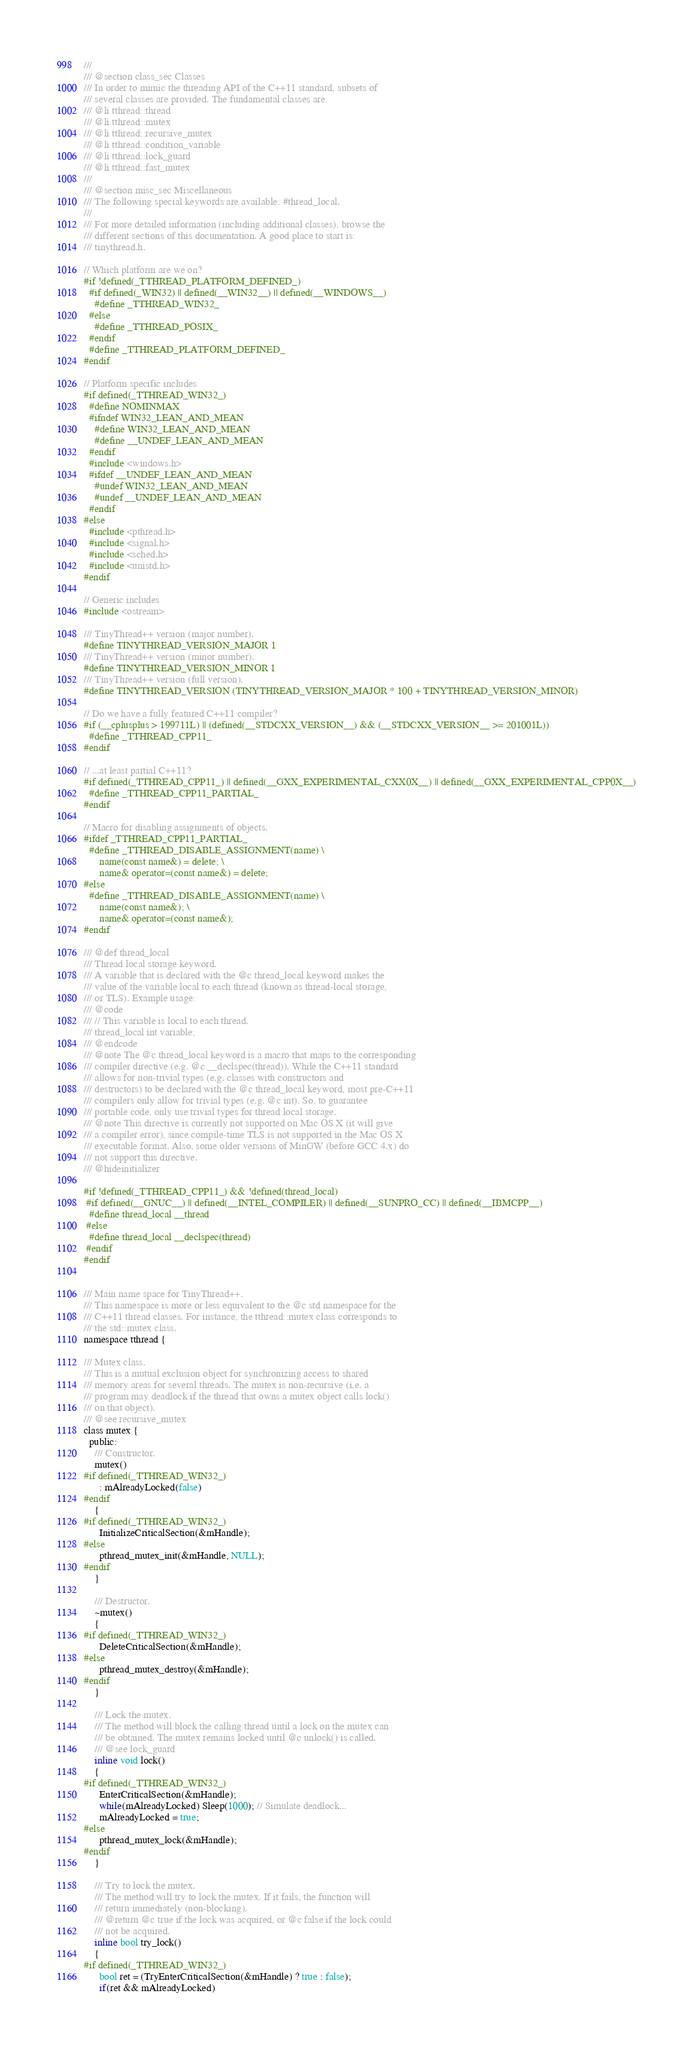Convert code to text. <code><loc_0><loc_0><loc_500><loc_500><_C_>///
/// @section class_sec Classes
/// In order to mimic the threading API of the C++11 standard, subsets of
/// several classes are provided. The fundamental classes are:
/// @li tthread::thread
/// @li tthread::mutex
/// @li tthread::recursive_mutex
/// @li tthread::condition_variable
/// @li tthread::lock_guard
/// @li tthread::fast_mutex
///
/// @section misc_sec Miscellaneous
/// The following special keywords are available: #thread_local.
///
/// For more detailed information (including additional classes), browse the
/// different sections of this documentation. A good place to start is:
/// tinythread.h.

// Which platform are we on?
#if !defined(_TTHREAD_PLATFORM_DEFINED_)
  #if defined(_WIN32) || defined(__WIN32__) || defined(__WINDOWS__)
    #define _TTHREAD_WIN32_
  #else
    #define _TTHREAD_POSIX_
  #endif
  #define _TTHREAD_PLATFORM_DEFINED_
#endif

// Platform specific includes
#if defined(_TTHREAD_WIN32_)
  #define NOMINMAX
  #ifndef WIN32_LEAN_AND_MEAN
    #define WIN32_LEAN_AND_MEAN
    #define __UNDEF_LEAN_AND_MEAN
  #endif
  #include <windows.h>
  #ifdef __UNDEF_LEAN_AND_MEAN
    #undef WIN32_LEAN_AND_MEAN
    #undef __UNDEF_LEAN_AND_MEAN
  #endif
#else
  #include <pthread.h>
  #include <signal.h>
  #include <sched.h>
  #include <unistd.h>
#endif

// Generic includes
#include <ostream>

/// TinyThread++ version (major number).
#define TINYTHREAD_VERSION_MAJOR 1
/// TinyThread++ version (minor number).
#define TINYTHREAD_VERSION_MINOR 1
/// TinyThread++ version (full version).
#define TINYTHREAD_VERSION (TINYTHREAD_VERSION_MAJOR * 100 + TINYTHREAD_VERSION_MINOR)

// Do we have a fully featured C++11 compiler?
#if (__cplusplus > 199711L) || (defined(__STDCXX_VERSION__) && (__STDCXX_VERSION__ >= 201001L))
  #define _TTHREAD_CPP11_
#endif

// ...at least partial C++11?
#if defined(_TTHREAD_CPP11_) || defined(__GXX_EXPERIMENTAL_CXX0X__) || defined(__GXX_EXPERIMENTAL_CPP0X__)
  #define _TTHREAD_CPP11_PARTIAL_
#endif

// Macro for disabling assignments of objects.
#ifdef _TTHREAD_CPP11_PARTIAL_
  #define _TTHREAD_DISABLE_ASSIGNMENT(name) \
      name(const name&) = delete; \
      name& operator=(const name&) = delete;
#else
  #define _TTHREAD_DISABLE_ASSIGNMENT(name) \
      name(const name&); \
      name& operator=(const name&);
#endif

/// @def thread_local
/// Thread local storage keyword.
/// A variable that is declared with the @c thread_local keyword makes the
/// value of the variable local to each thread (known as thread-local storage,
/// or TLS). Example usage:
/// @code
/// // This variable is local to each thread.
/// thread_local int variable;
/// @endcode
/// @note The @c thread_local keyword is a macro that maps to the corresponding
/// compiler directive (e.g. @c __declspec(thread)). While the C++11 standard
/// allows for non-trivial types (e.g. classes with constructors and
/// destructors) to be declared with the @c thread_local keyword, most pre-C++11
/// compilers only allow for trivial types (e.g. @c int). So, to guarantee
/// portable code, only use trivial types for thread local storage.
/// @note This directive is currently not supported on Mac OS X (it will give
/// a compiler error), since compile-time TLS is not supported in the Mac OS X
/// executable format. Also, some older versions of MinGW (before GCC 4.x) do
/// not support this directive.
/// @hideinitializer

#if !defined(_TTHREAD_CPP11_) && !defined(thread_local)
 #if defined(__GNUC__) || defined(__INTEL_COMPILER) || defined(__SUNPRO_CC) || defined(__IBMCPP__)
  #define thread_local __thread
 #else
  #define thread_local __declspec(thread)
 #endif
#endif


/// Main name space for TinyThread++.
/// This namespace is more or less equivalent to the @c std namespace for the
/// C++11 thread classes. For instance, the tthread::mutex class corresponds to
/// the std::mutex class.
namespace tthread {

/// Mutex class.
/// This is a mutual exclusion object for synchronizing access to shared
/// memory areas for several threads. The mutex is non-recursive (i.e. a
/// program may deadlock if the thread that owns a mutex object calls lock()
/// on that object).
/// @see recursive_mutex
class mutex {
  public:
    /// Constructor.
    mutex()
#if defined(_TTHREAD_WIN32_)
      : mAlreadyLocked(false)
#endif
    {
#if defined(_TTHREAD_WIN32_)
      InitializeCriticalSection(&mHandle);
#else
      pthread_mutex_init(&mHandle, NULL);
#endif
    }

    /// Destructor.
    ~mutex()
    {
#if defined(_TTHREAD_WIN32_)
      DeleteCriticalSection(&mHandle);
#else
      pthread_mutex_destroy(&mHandle);
#endif
    }

    /// Lock the mutex.
    /// The method will block the calling thread until a lock on the mutex can
    /// be obtained. The mutex remains locked until @c unlock() is called.
    /// @see lock_guard
    inline void lock()
    {
#if defined(_TTHREAD_WIN32_)
      EnterCriticalSection(&mHandle);
      while(mAlreadyLocked) Sleep(1000); // Simulate deadlock...
      mAlreadyLocked = true;
#else
      pthread_mutex_lock(&mHandle);
#endif
    }

    /// Try to lock the mutex.
    /// The method will try to lock the mutex. If it fails, the function will
    /// return immediately (non-blocking).
    /// @return @c true if the lock was acquired, or @c false if the lock could
    /// not be acquired.
    inline bool try_lock()
    {
#if defined(_TTHREAD_WIN32_)
      bool ret = (TryEnterCriticalSection(&mHandle) ? true : false);
      if(ret && mAlreadyLocked)</code> 